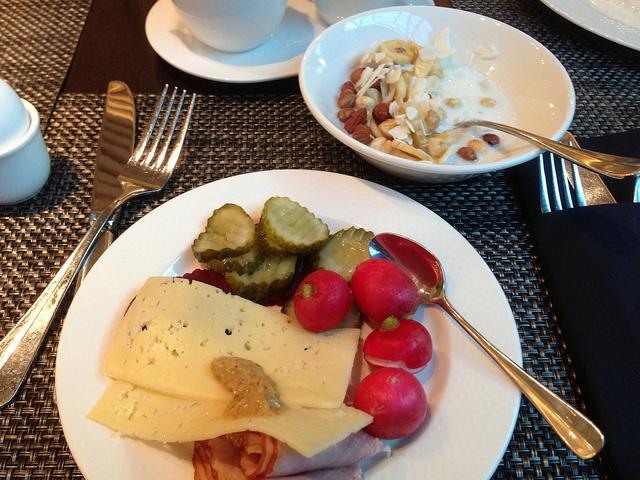What is the green stuff called on the plate? pickles 